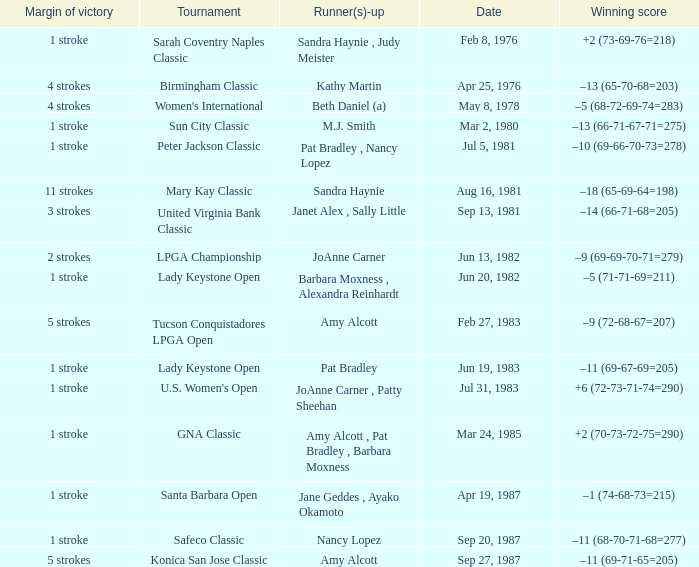What is the margin of victory when the tournament is konica san jose classic? 5 strokes. 